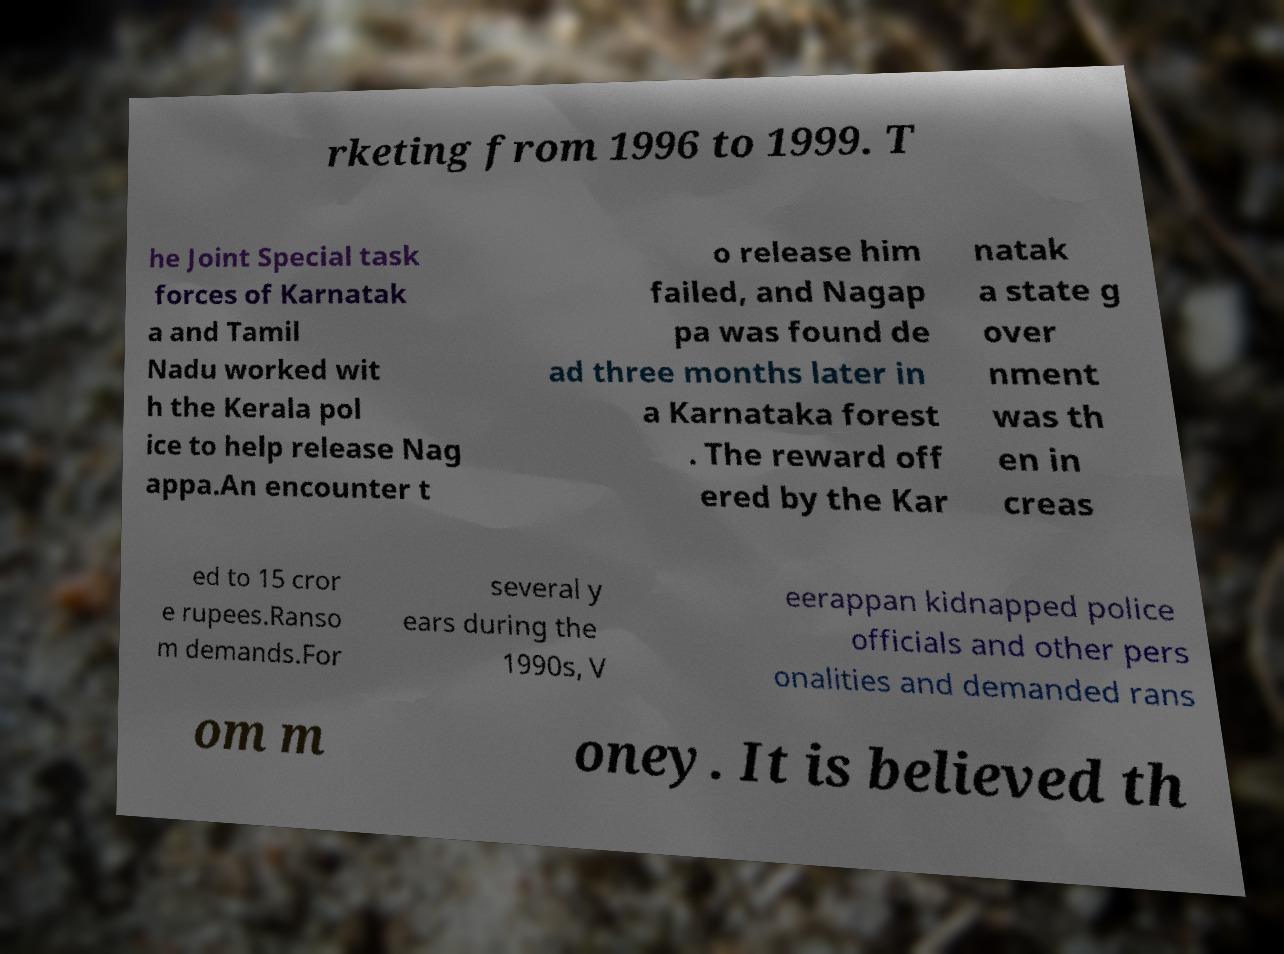Could you assist in decoding the text presented in this image and type it out clearly? rketing from 1996 to 1999. T he Joint Special task forces of Karnatak a and Tamil Nadu worked wit h the Kerala pol ice to help release Nag appa.An encounter t o release him failed, and Nagap pa was found de ad three months later in a Karnataka forest . The reward off ered by the Kar natak a state g over nment was th en in creas ed to 15 cror e rupees.Ranso m demands.For several y ears during the 1990s, V eerappan kidnapped police officials and other pers onalities and demanded rans om m oney. It is believed th 